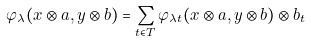<formula> <loc_0><loc_0><loc_500><loc_500>\varphi _ { \lambda } ( x \otimes a , y \otimes b ) = \sum _ { t \in T } \varphi _ { \lambda t } ( x \otimes a , y \otimes b ) \otimes b _ { t }</formula> 